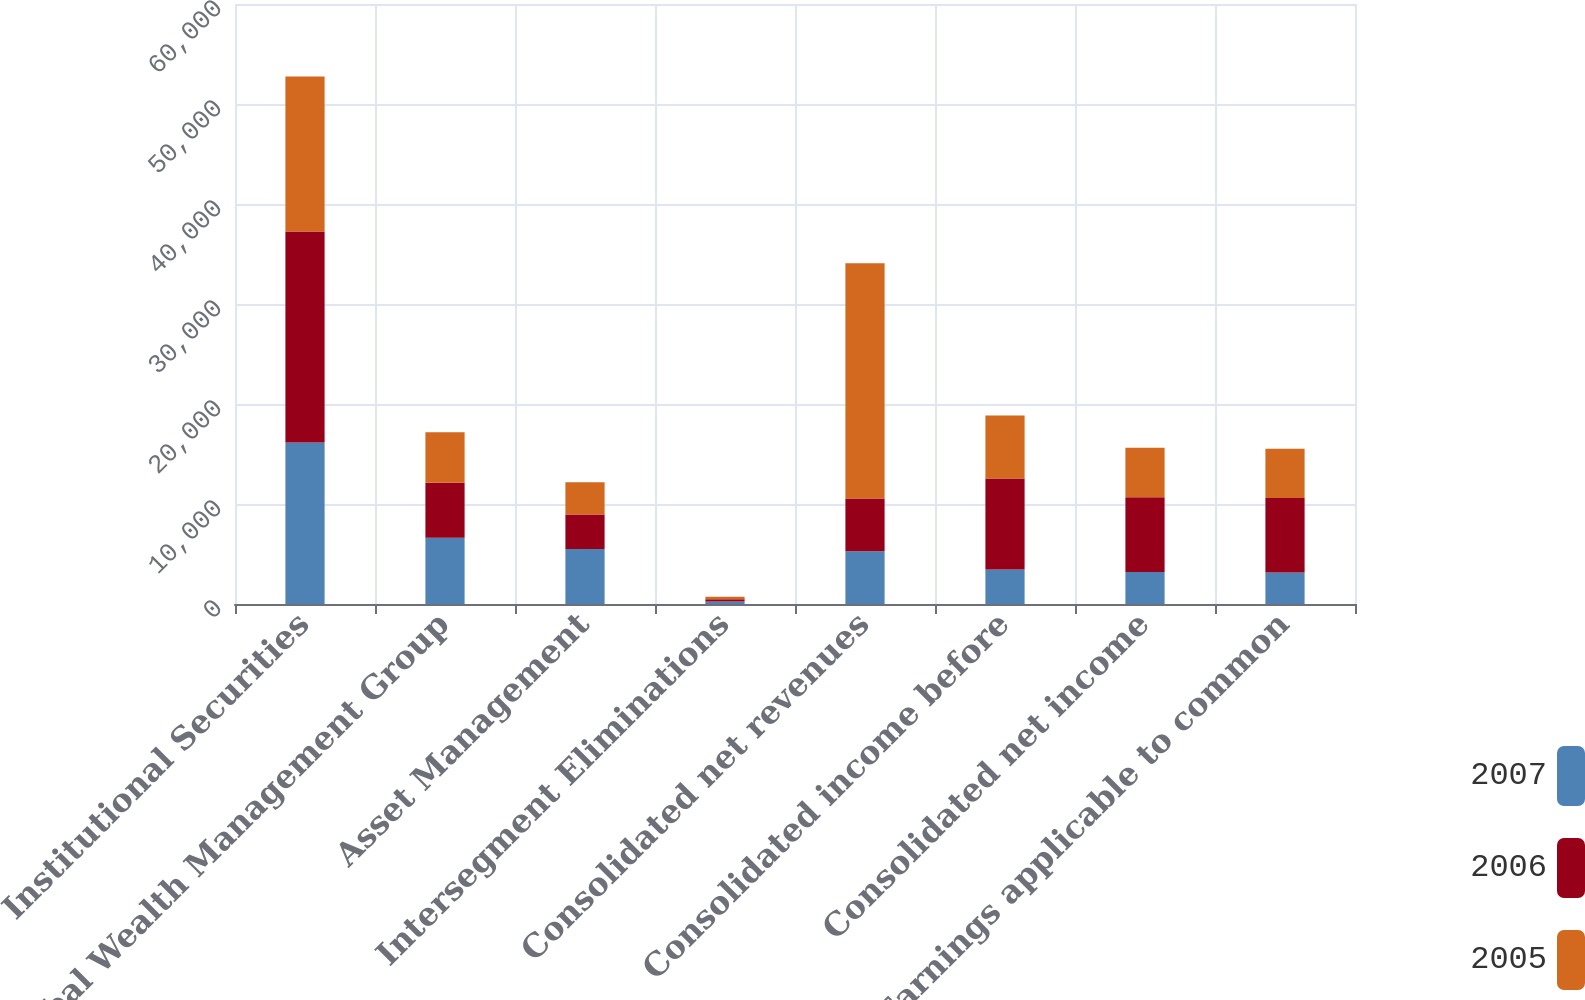<chart> <loc_0><loc_0><loc_500><loc_500><stacked_bar_chart><ecel><fcel>Institutional Securities<fcel>Global Wealth Management Group<fcel>Asset Management<fcel>Intersegment Eliminations<fcel>Consolidated net revenues<fcel>Consolidated income before<fcel>Consolidated net income<fcel>Earnings applicable to common<nl><fcel>2007<fcel>16149<fcel>6625<fcel>5493<fcel>241<fcel>5270<fcel>3441<fcel>3209<fcel>3141<nl><fcel>2006<fcel>21110<fcel>5512<fcel>3453<fcel>236<fcel>5270<fcel>9103<fcel>7472<fcel>7453<nl><fcel>2005<fcel>15497<fcel>5047<fcel>3219<fcel>238<fcel>23525<fcel>6316<fcel>4939<fcel>4939<nl></chart> 